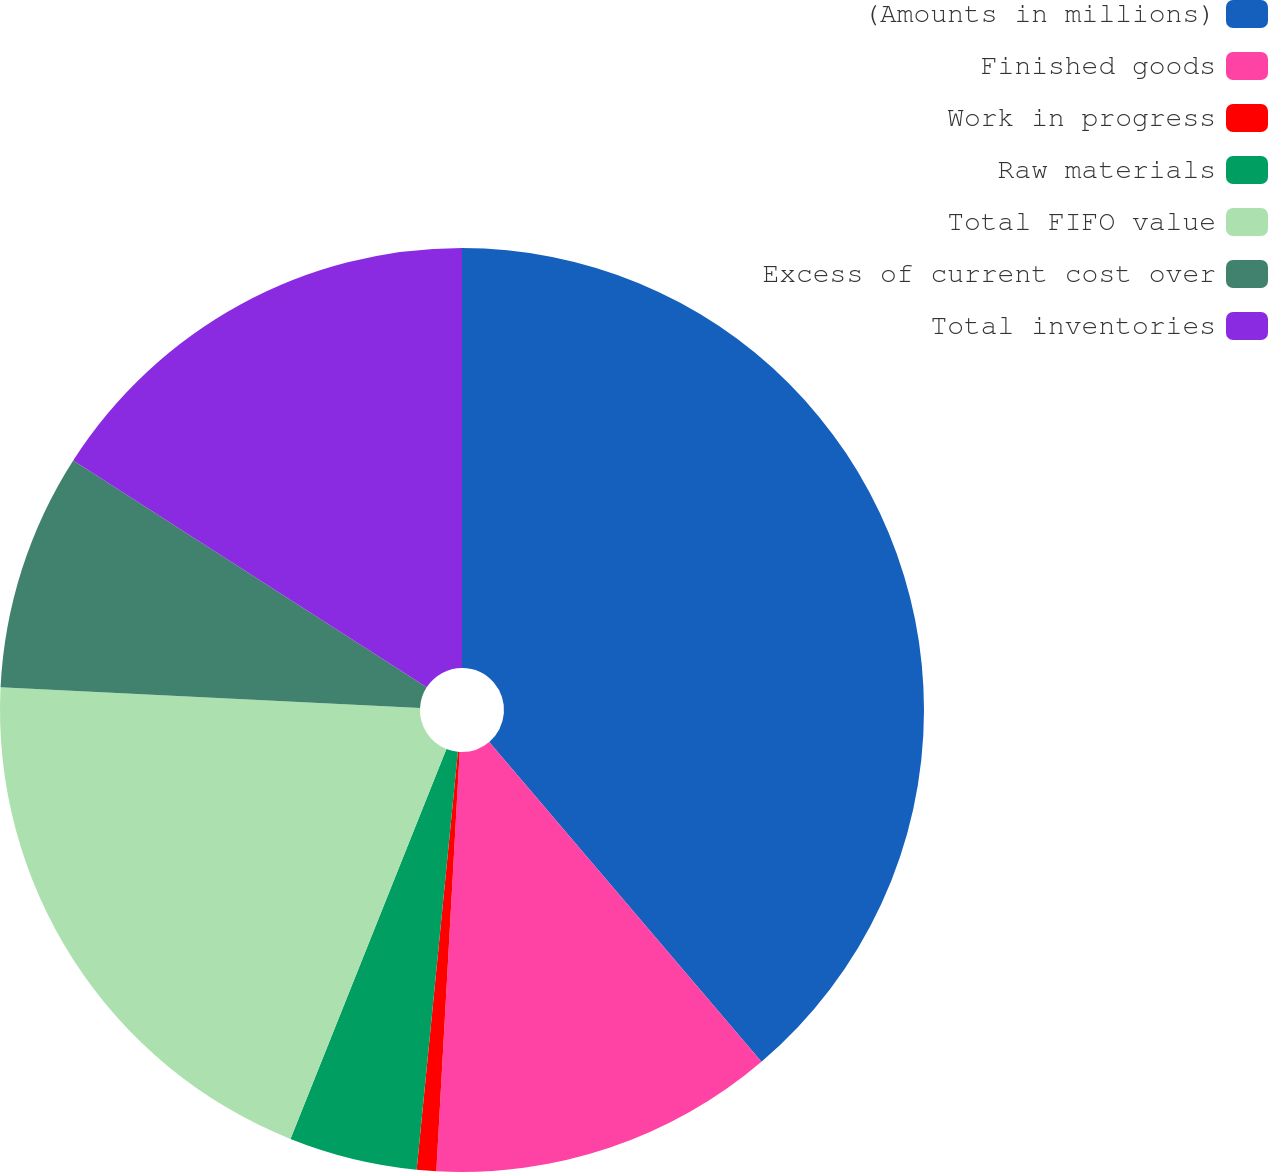Convert chart to OTSL. <chart><loc_0><loc_0><loc_500><loc_500><pie_chart><fcel>(Amounts in millions)<fcel>Finished goods<fcel>Work in progress<fcel>Raw materials<fcel>Total FIFO value<fcel>Excess of current cost over<fcel>Total inventories<nl><fcel>38.78%<fcel>12.11%<fcel>0.68%<fcel>4.49%<fcel>19.73%<fcel>8.3%<fcel>15.92%<nl></chart> 